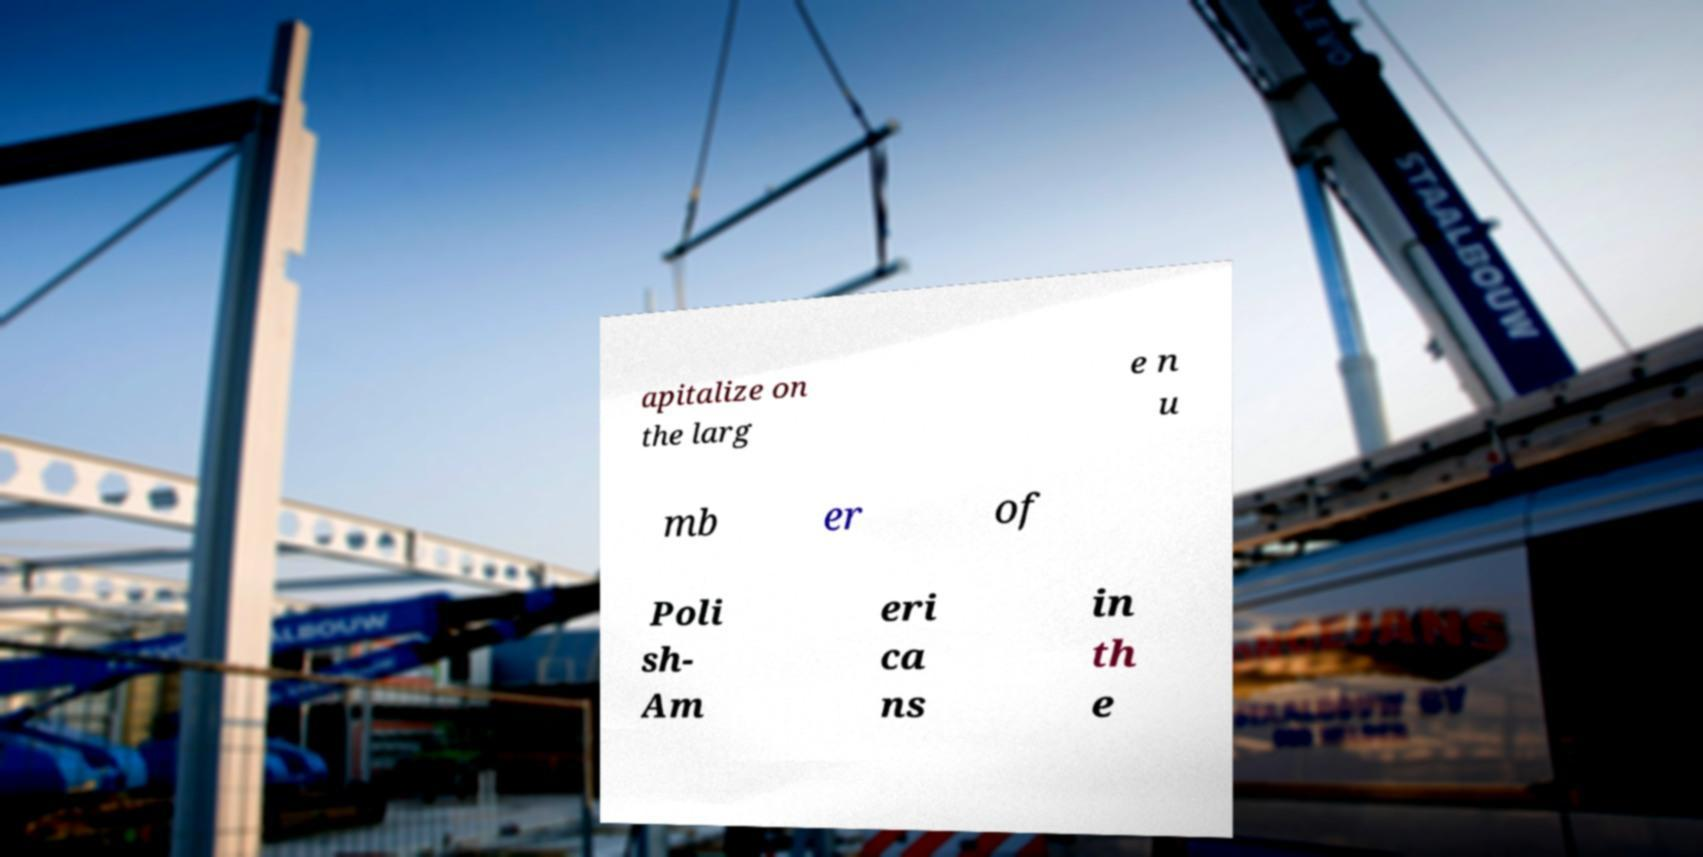Could you assist in decoding the text presented in this image and type it out clearly? apitalize on the larg e n u mb er of Poli sh- Am eri ca ns in th e 